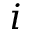<formula> <loc_0><loc_0><loc_500><loc_500>i</formula> 